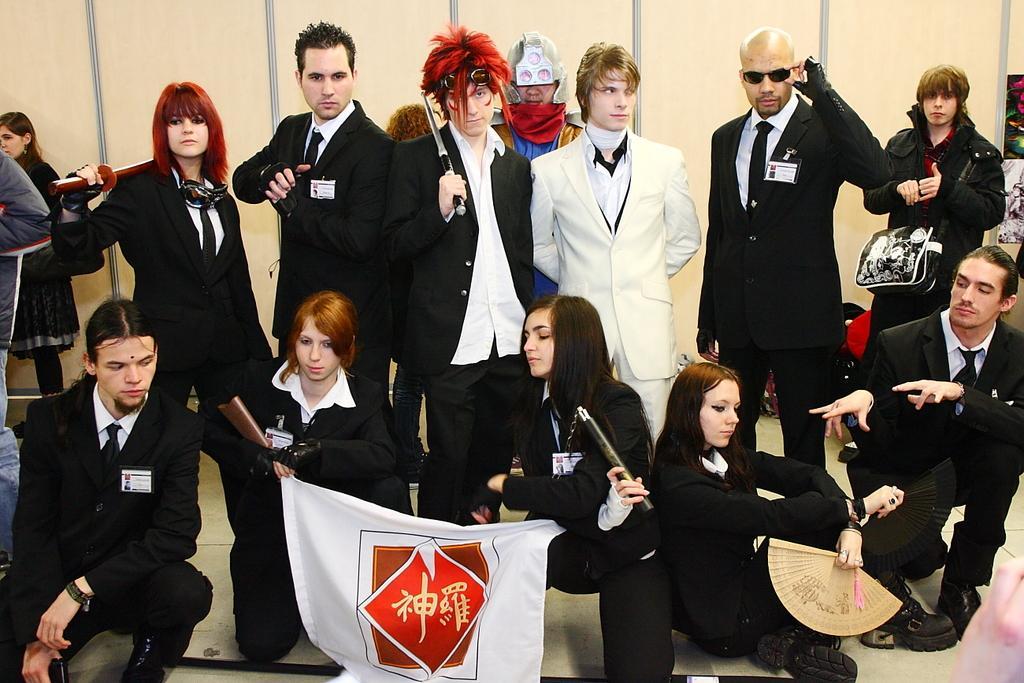Please provide a concise description of this image. In this picture we observe group of people who are wearing black coats are standing and there is a guy who is wearing a white coat and standing in between them. 